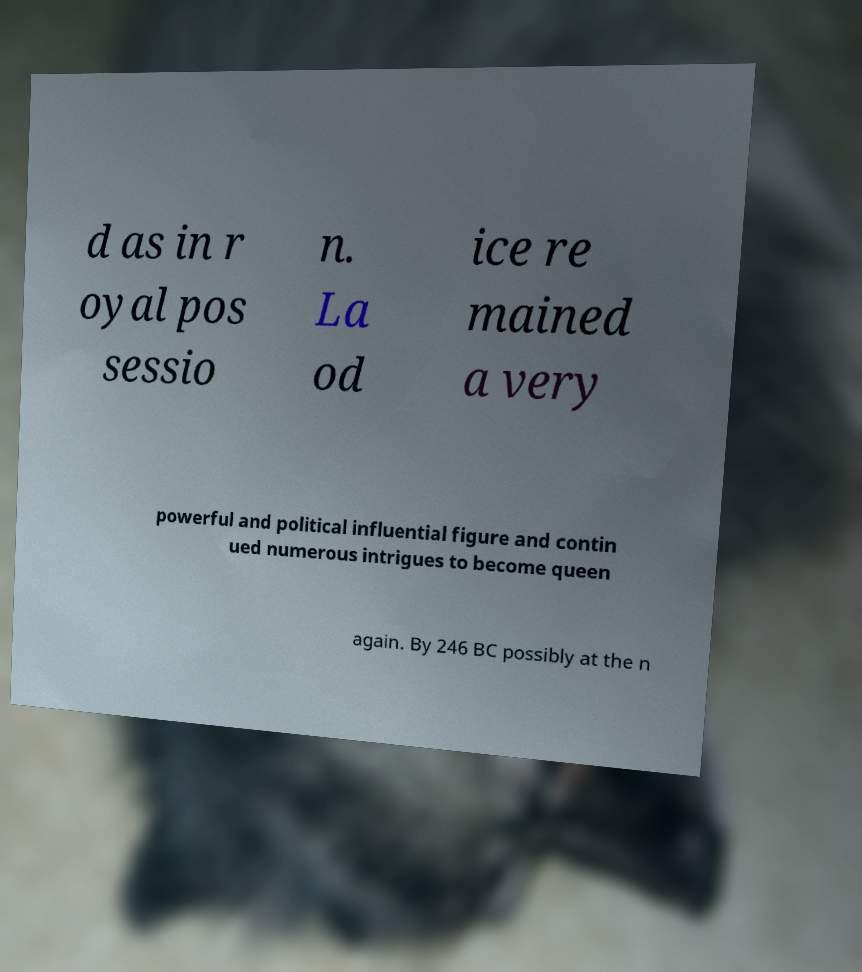Could you extract and type out the text from this image? d as in r oyal pos sessio n. La od ice re mained a very powerful and political influential figure and contin ued numerous intrigues to become queen again. By 246 BC possibly at the n 